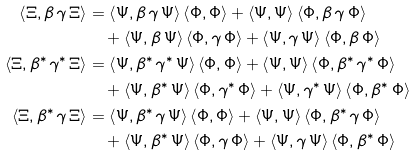Convert formula to latex. <formula><loc_0><loc_0><loc_500><loc_500>\left \langle \Xi , \beta \, \gamma \, \Xi \right \rangle & = \left \langle \Psi , \beta \, \gamma \, \Psi \right \rangle \left \langle \Phi , \Phi \right \rangle + \left \langle \Psi , \Psi \right \rangle \left \langle \Phi , \beta \, \gamma \, \Phi \right \rangle \\ & \quad + \left \langle \Psi , \beta \, \Psi \right \rangle \left \langle \Phi , \gamma \, \Phi \right \rangle + \left \langle \Psi , \gamma \, \Psi \right \rangle \left \langle \Phi , \beta \, \Phi \right \rangle \\ \left \langle \Xi , \beta ^ { * } \, \gamma ^ { * } \, \Xi \right \rangle & = \left \langle \Psi , \beta ^ { * } \, \gamma ^ { * } \, \Psi \right \rangle \left \langle \Phi , \Phi \right \rangle + \left \langle \Psi , \Psi \right \rangle \left \langle \Phi , \beta ^ { * } \, \gamma ^ { * } \, \Phi \right \rangle \\ & \quad + \left \langle \Psi , \beta ^ { * } \, \Psi \right \rangle \left \langle \Phi , \gamma ^ { * } \, \Phi \right \rangle + \left \langle \Psi , \gamma ^ { * } \, \Psi \right \rangle \left \langle \Phi , \beta ^ { * } \, \Phi \right \rangle \\ \left \langle \Xi , \beta ^ { * } \, \gamma \, \Xi \right \rangle & = \left \langle \Psi , \beta ^ { * } \, \gamma \, \Psi \right \rangle \left \langle \Phi , \Phi \right \rangle + \left \langle \Psi , \Psi \right \rangle \left \langle \Phi , \beta ^ { * } \, \gamma \, \Phi \right \rangle \\ & \quad + \left \langle \Psi , \beta ^ { * } \, \Psi \right \rangle \left \langle \Phi , \gamma \, \Phi \right \rangle + \left \langle \Psi , \gamma \, \Psi \right \rangle \left \langle \Phi , \beta ^ { * } \, \Phi \right \rangle</formula> 